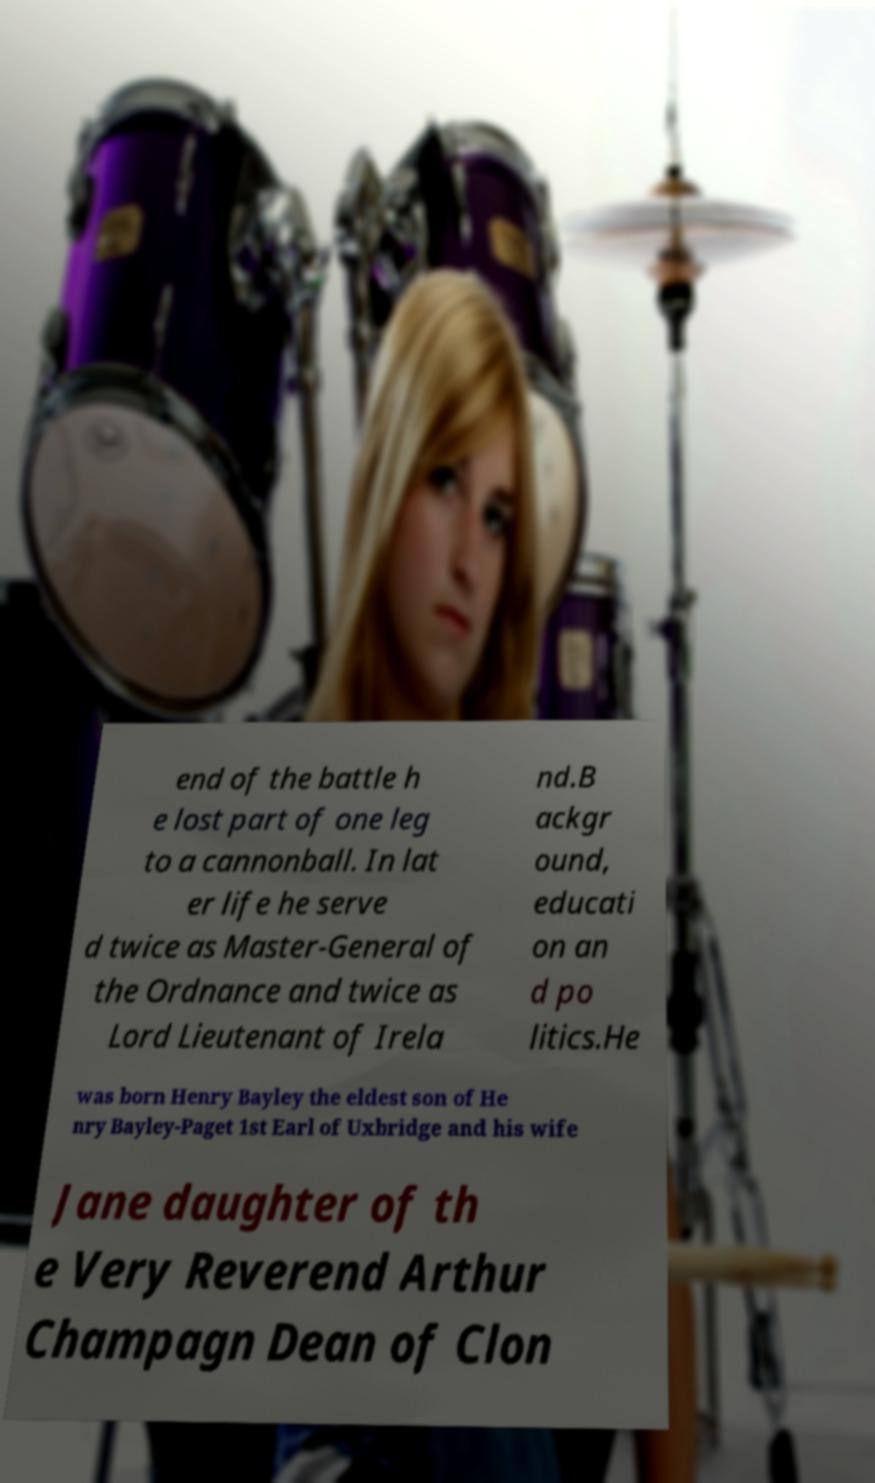I need the written content from this picture converted into text. Can you do that? end of the battle h e lost part of one leg to a cannonball. In lat er life he serve d twice as Master-General of the Ordnance and twice as Lord Lieutenant of Irela nd.B ackgr ound, educati on an d po litics.He was born Henry Bayley the eldest son of He nry Bayley-Paget 1st Earl of Uxbridge and his wife Jane daughter of th e Very Reverend Arthur Champagn Dean of Clon 